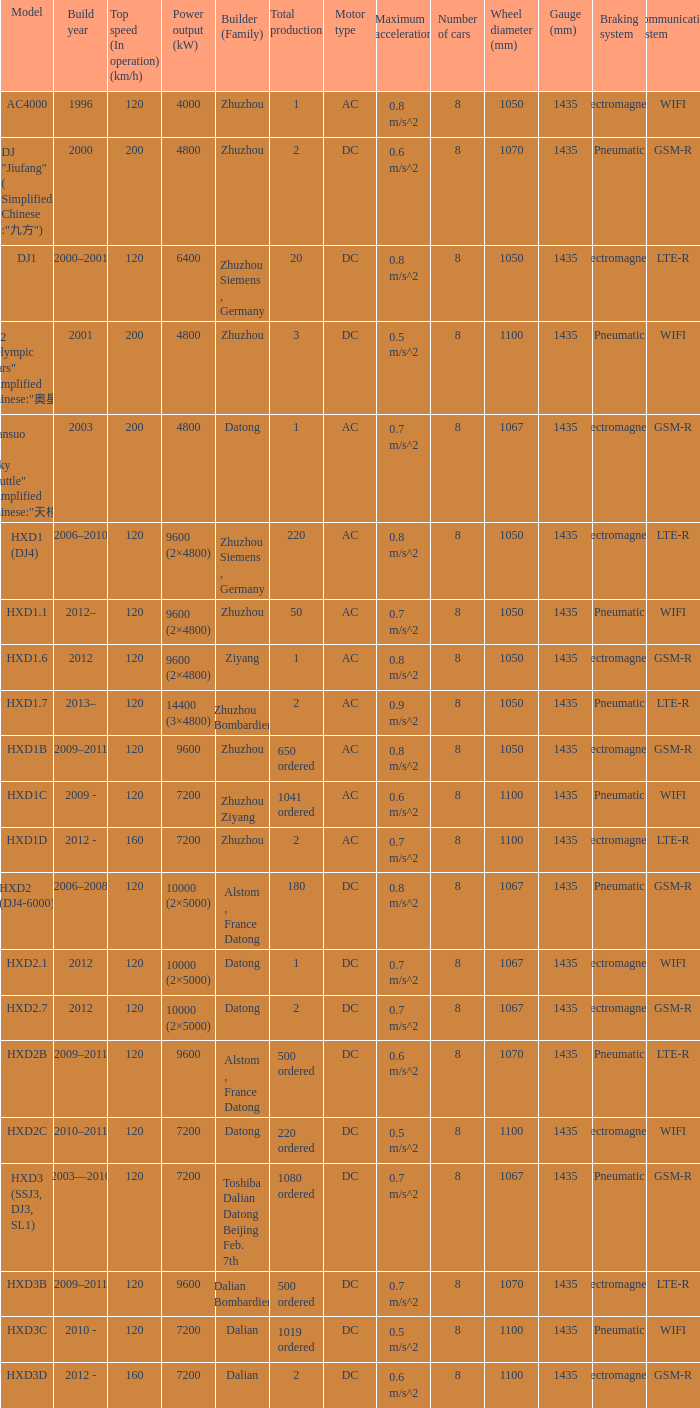What is the power output (kw) of model hxd3d? 7200.0. 